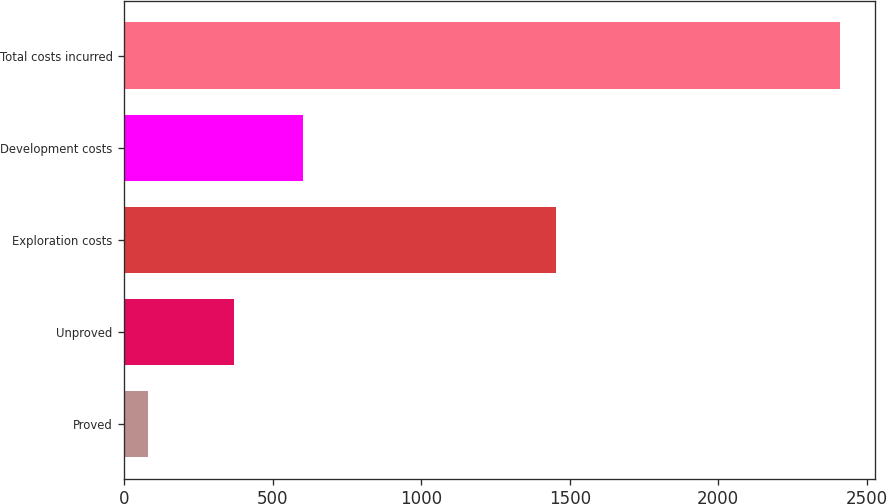Convert chart to OTSL. <chart><loc_0><loc_0><loc_500><loc_500><bar_chart><fcel>Proved<fcel>Unproved<fcel>Exploration costs<fcel>Development costs<fcel>Total costs incurred<nl><fcel>78<fcel>368<fcel>1454<fcel>601.1<fcel>2409<nl></chart> 